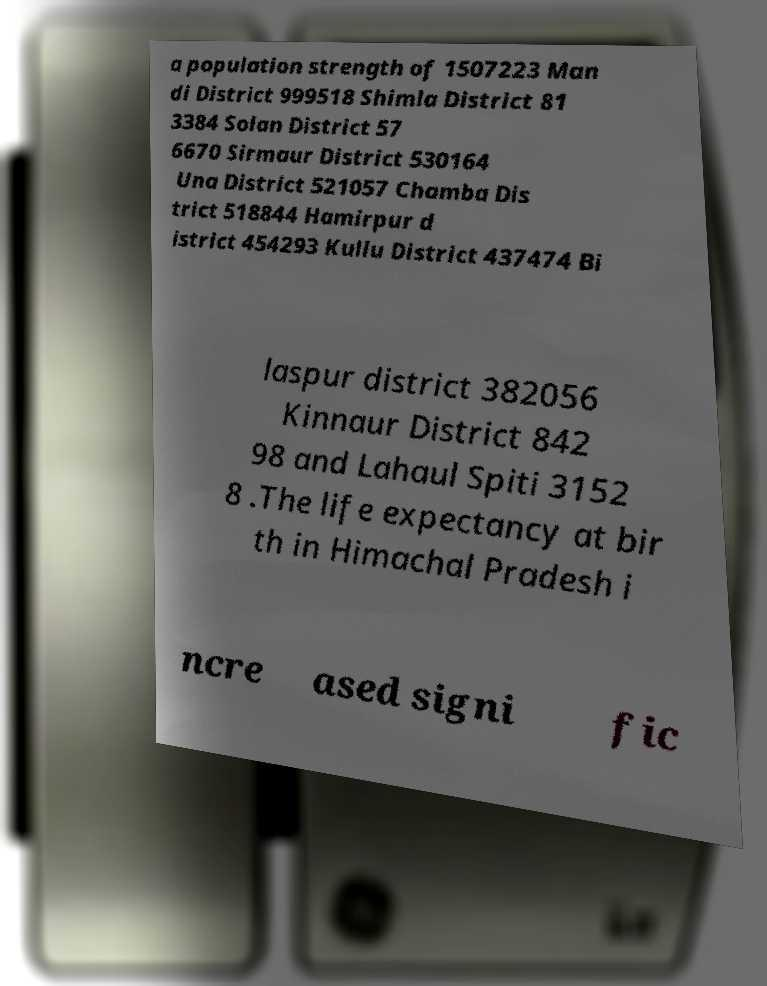Please read and relay the text visible in this image. What does it say? a population strength of 1507223 Man di District 999518 Shimla District 81 3384 Solan District 57 6670 Sirmaur District 530164 Una District 521057 Chamba Dis trict 518844 Hamirpur d istrict 454293 Kullu District 437474 Bi laspur district 382056 Kinnaur District 842 98 and Lahaul Spiti 3152 8 .The life expectancy at bir th in Himachal Pradesh i ncre ased signi fic 